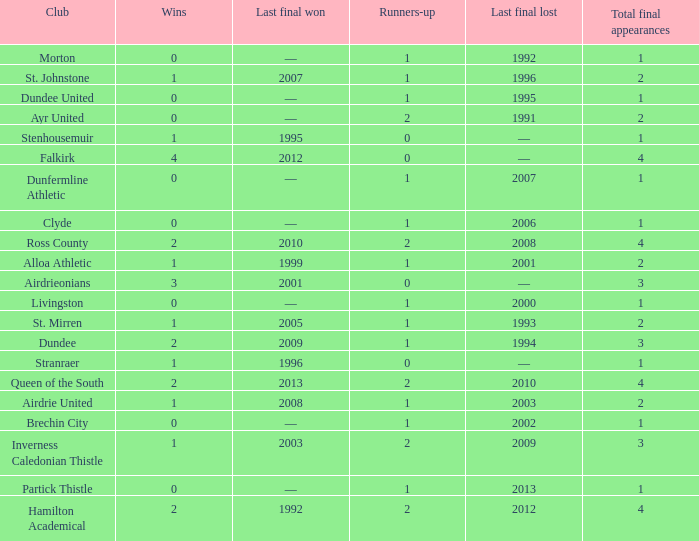What club has over 1 runners-up and last won the final in 2010? Ross County. 